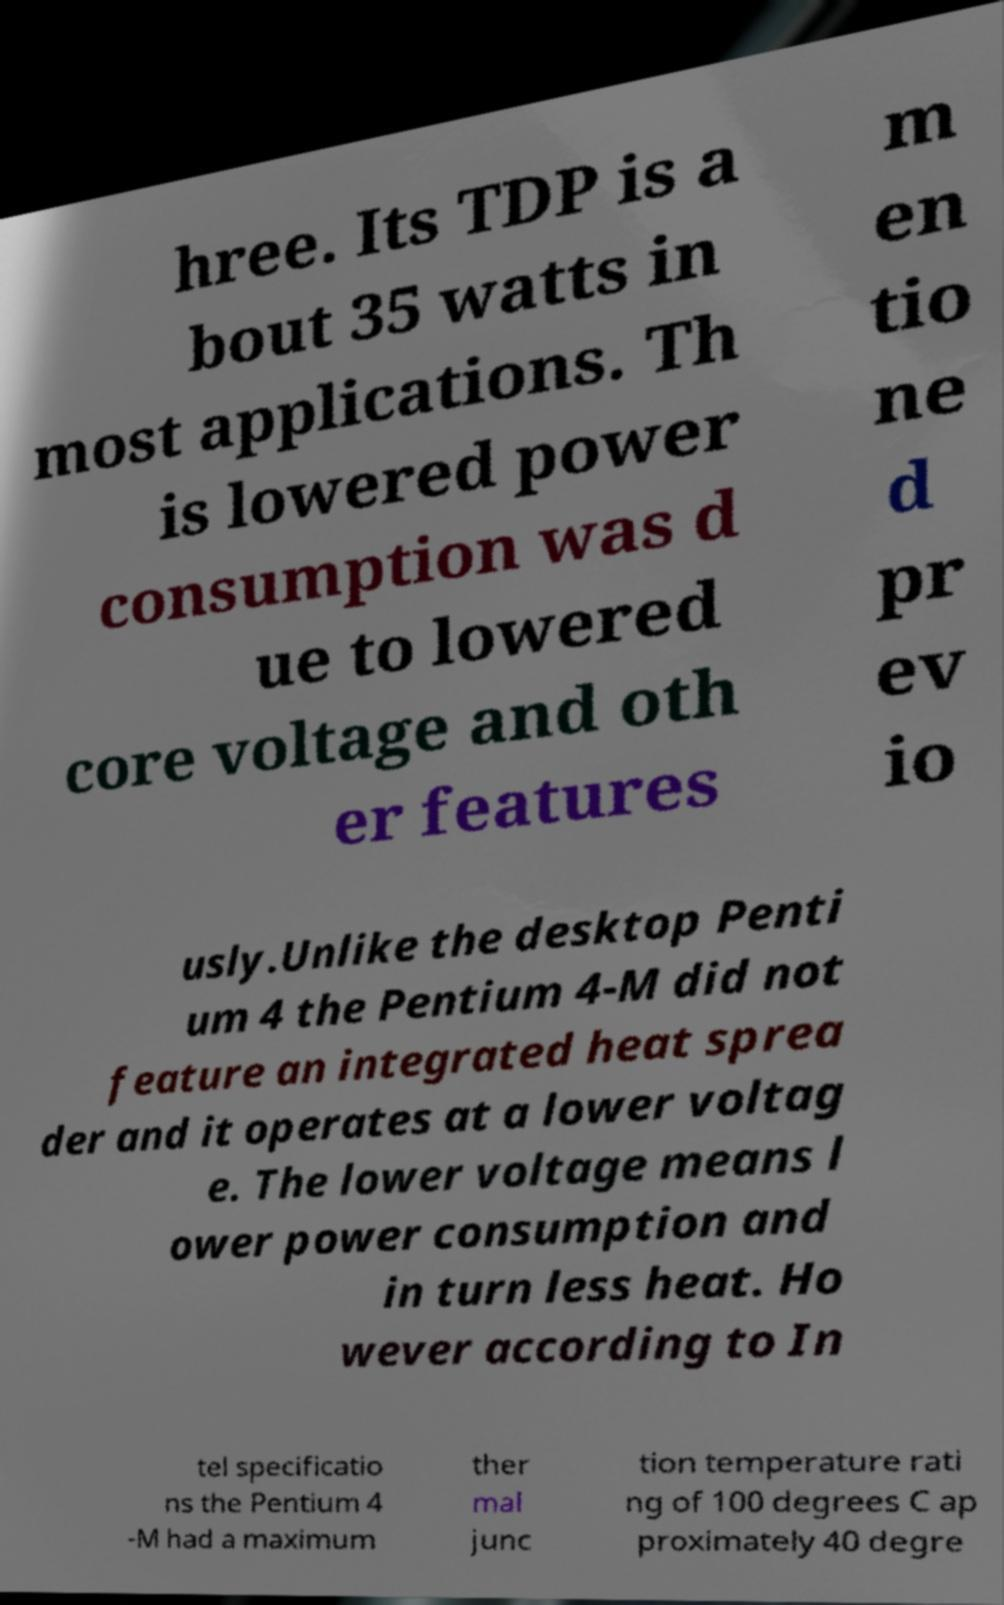Please read and relay the text visible in this image. What does it say? hree. Its TDP is a bout 35 watts in most applications. Th is lowered power consumption was d ue to lowered core voltage and oth er features m en tio ne d pr ev io usly.Unlike the desktop Penti um 4 the Pentium 4-M did not feature an integrated heat sprea der and it operates at a lower voltag e. The lower voltage means l ower power consumption and in turn less heat. Ho wever according to In tel specificatio ns the Pentium 4 -M had a maximum ther mal junc tion temperature rati ng of 100 degrees C ap proximately 40 degre 